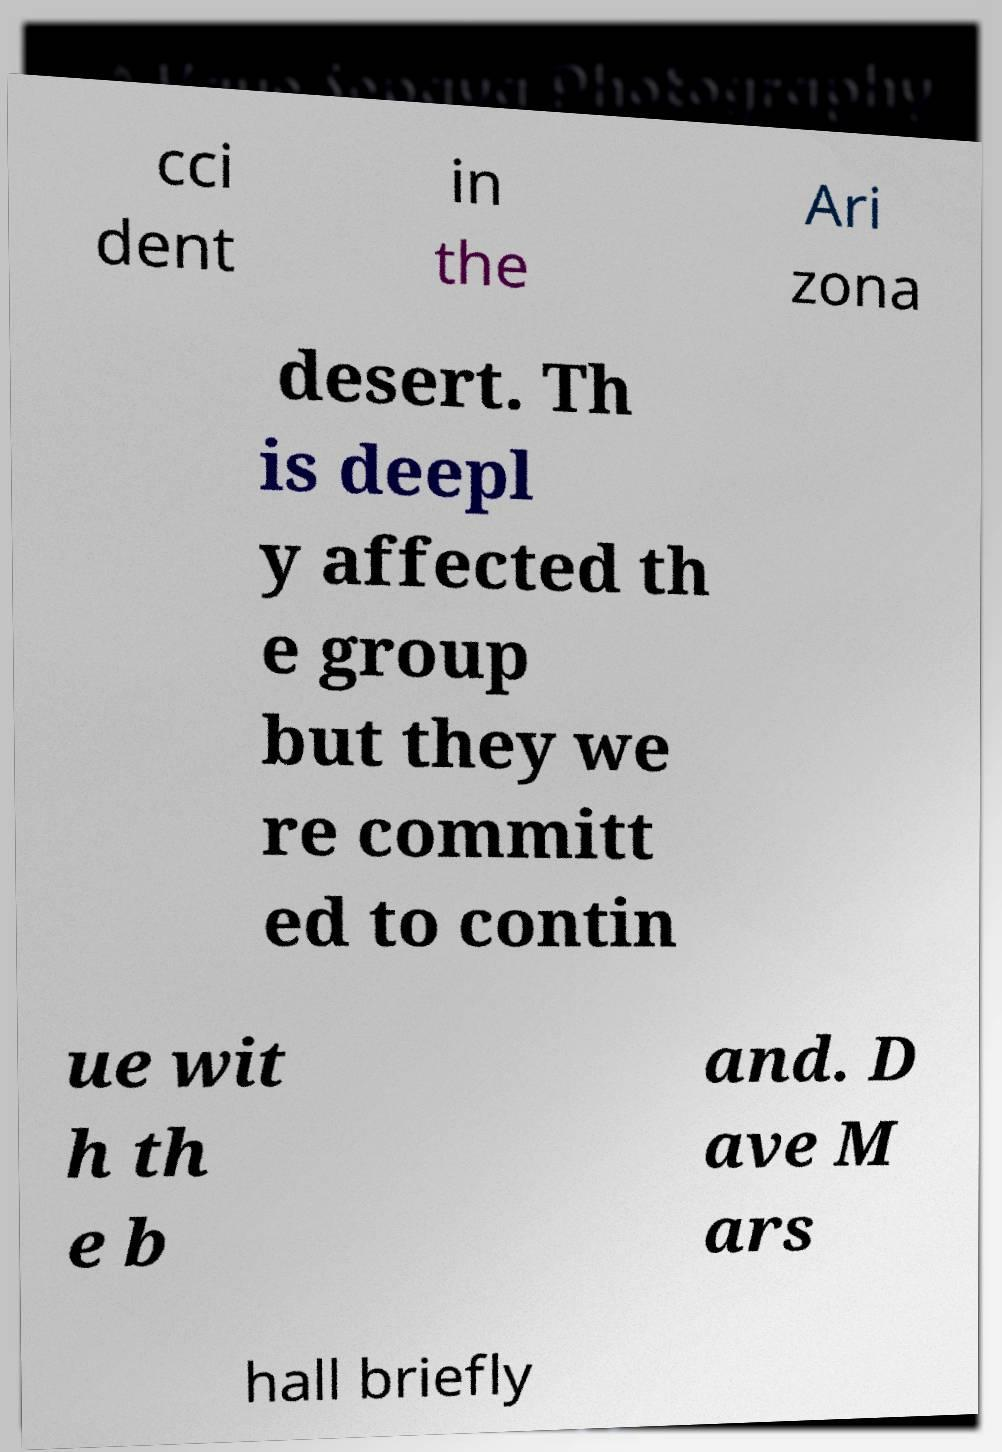Please read and relay the text visible in this image. What does it say? cci dent in the Ari zona desert. Th is deepl y affected th e group but they we re committ ed to contin ue wit h th e b and. D ave M ars hall briefly 